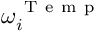Convert formula to latex. <formula><loc_0><loc_0><loc_500><loc_500>\omega _ { i } ^ { T e m p }</formula> 